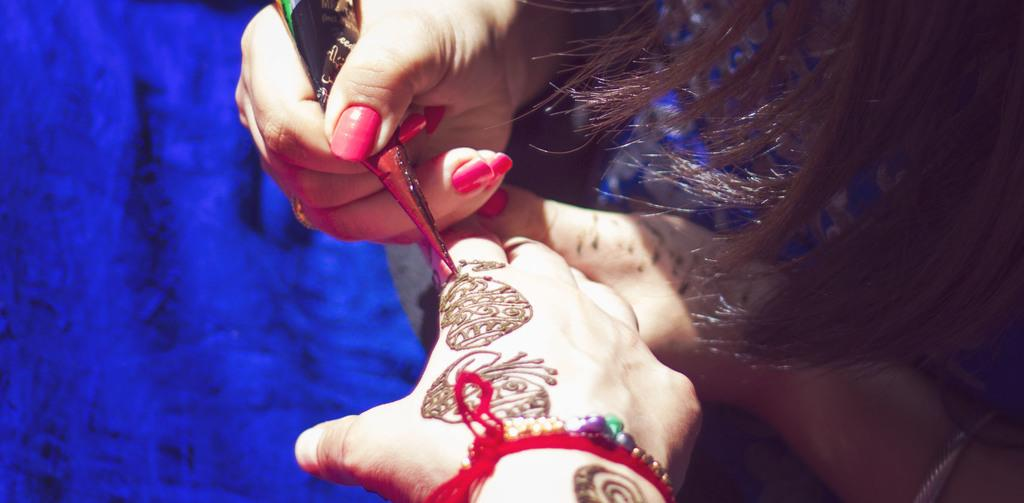What is the lady in the image doing? The lady is applying mehndi. Who is the lady applying mehndi to? There is another person in the image who is receiving the mehndi application. Can you describe the activity taking place in the image? The lady is applying mehndi to the other person. What type of scarf is being used to turn the page in the image? There is no scarf or page present in the image; the lady is applying mehndi to another person. 